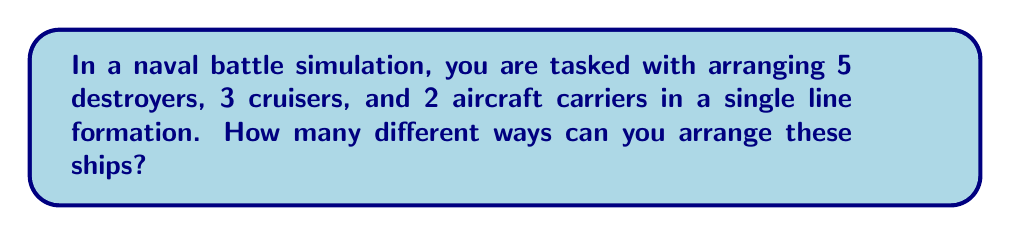Can you answer this question? Let's approach this step-by-step:

1) First, we need to recognize that this is a permutation problem. We are arranging all the ships in a line, and the order matters.

2) The total number of ships is:
   $5 + 3 + 2 = 10$ ships

3) If all ships were different, we would have 10! ways to arrange them. However, we have multiple ships of the same type, which introduces repetition.

4) To account for this repetition, we need to divide by the number of ways to arrange each type of ship:
   - 5! for the 5 destroyers
   - 3! for the 3 cruisers
   - 2! for the 2 aircraft carriers

5) The formula for this type of problem is:

   $\frac{n!}{n_1! \cdot n_2! \cdot n_3!}$

   Where $n$ is the total number of ships, and $n_1$, $n_2$, $n_3$ are the numbers of each type of ship.

6) Plugging in our numbers:

   $\frac{10!}{5! \cdot 3! \cdot 2!}$

7) Let's calculate this:
   
   $\frac{10 \cdot 9 \cdot 8 \cdot 7 \cdot 6 \cdot 5!}{5! \cdot 3 \cdot 2 \cdot 1 \cdot 2 \cdot 1}$

8) The 5! cancels out in the numerator and denominator:

   $\frac{10 \cdot 9 \cdot 8 \cdot 7 \cdot 6}{3 \cdot 2 \cdot 2}$

9) Multiply the numerator and denominator:

   $\frac{30240}{12} = 2520$

Therefore, there are 2520 different ways to arrange these ships in a line formation.
Answer: 2520 